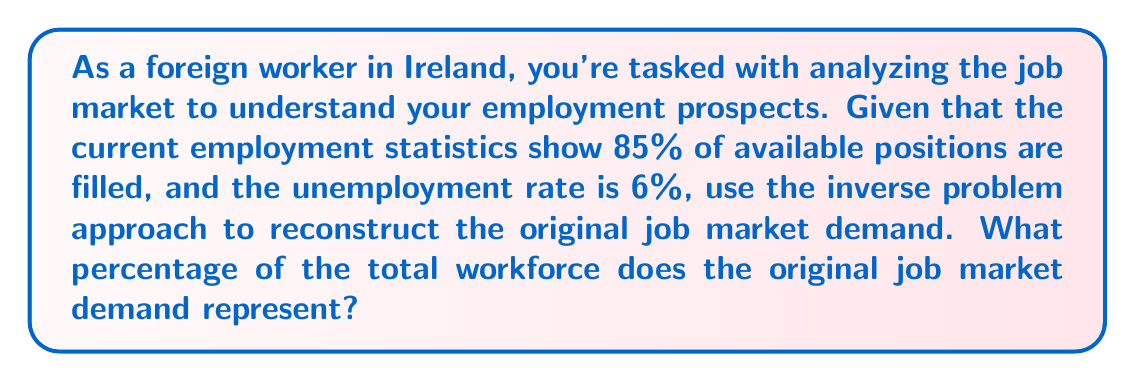Provide a solution to this math problem. Let's approach this step-by-step:

1) First, we need to understand what the given information represents:
   - 85% of available positions are filled
   - The unemployment rate is 6%

2) Let's define variables:
   $x$ = total workforce (employed + unemployed)
   $y$ = original job market demand

3) We know that 85% of $y$ is filled, which means:
   $0.85y = 0.94x$ (since 94% of the workforce is employed)

4) We can express this as an equation:
   $$y = \frac{0.94x}{0.85}$$

5) Simplifying:
   $$y = 1.1059x$$

6) This means the original job market demand is approximately 110.59% of the total workforce.

7) To express this as a percentage of the total workforce:
   $1.1059 * 100\% = 110.59\%$

This inverse problem approach allows us to reconstruct the original job market demand from the current employment statistics.
Answer: 110.59% 